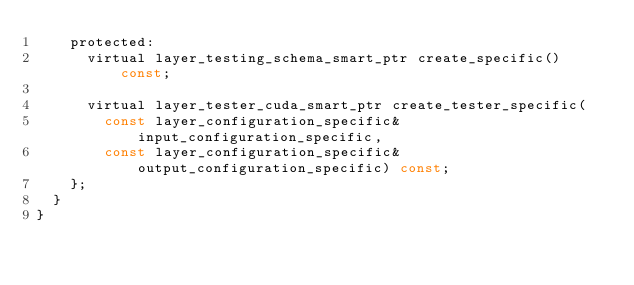<code> <loc_0><loc_0><loc_500><loc_500><_C_>		protected:
			virtual layer_testing_schema_smart_ptr create_specific() const;

			virtual layer_tester_cuda_smart_ptr create_tester_specific(
				const layer_configuration_specific& input_configuration_specific,
				const layer_configuration_specific& output_configuration_specific) const;
		};
	}
}</code> 